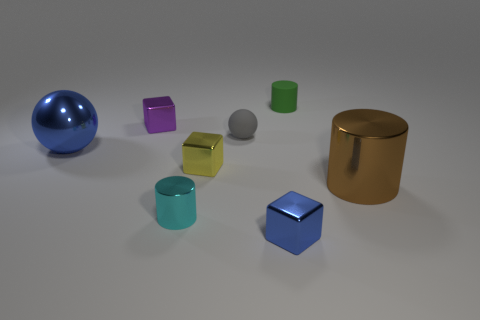Subtract all yellow cubes. How many cubes are left? 2 Subtract all small cylinders. How many cylinders are left? 1 Add 1 small balls. How many objects exist? 9 Subtract all balls. How many objects are left? 6 Subtract all yellow spheres. How many brown cylinders are left? 1 Subtract all metallic things. Subtract all small gray rubber spheres. How many objects are left? 1 Add 1 small cubes. How many small cubes are left? 4 Add 3 yellow shiny cubes. How many yellow shiny cubes exist? 4 Subtract 0 brown balls. How many objects are left? 8 Subtract 1 cubes. How many cubes are left? 2 